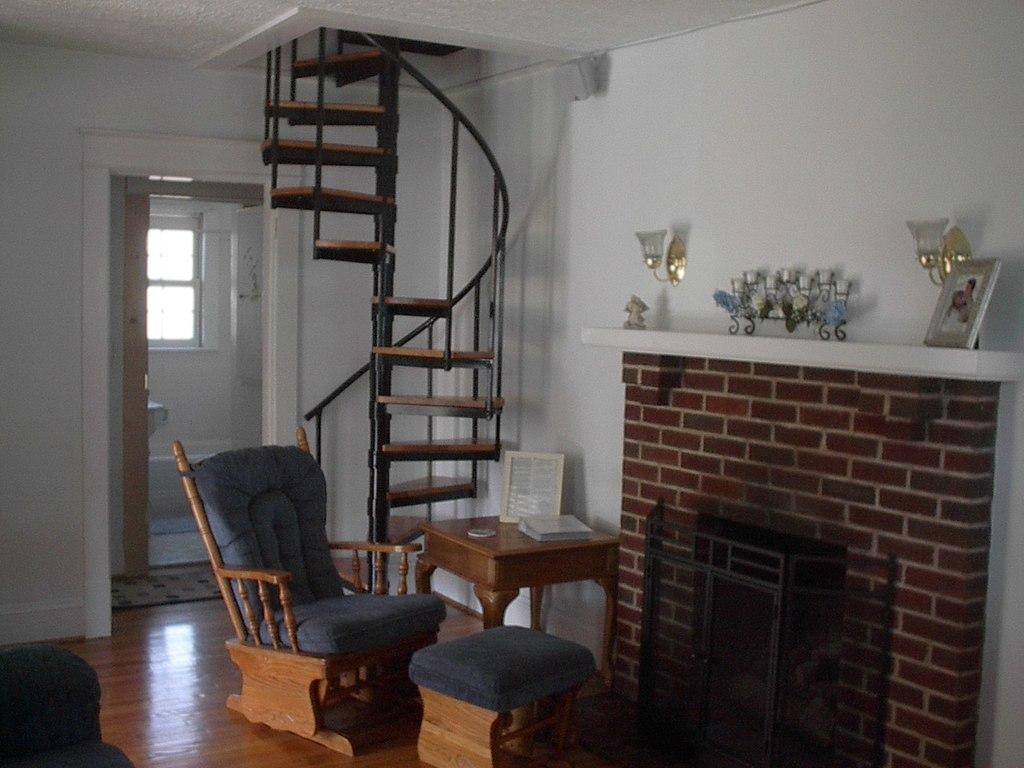What type of furniture is present in the image? There is a sofa and a stool in the image. What can be seen on the right side of the image? There is a fireplace on the right side of the image. What architectural features are visible in the background of the image? There is a wall, stairs, and a door in the background of the image. What type of crime is being committed in the image? There is no indication of any crime being committed in the image. How low is the stool in the image? The height of the stool cannot be determined from the image alone, as there is no reference point for comparison. 